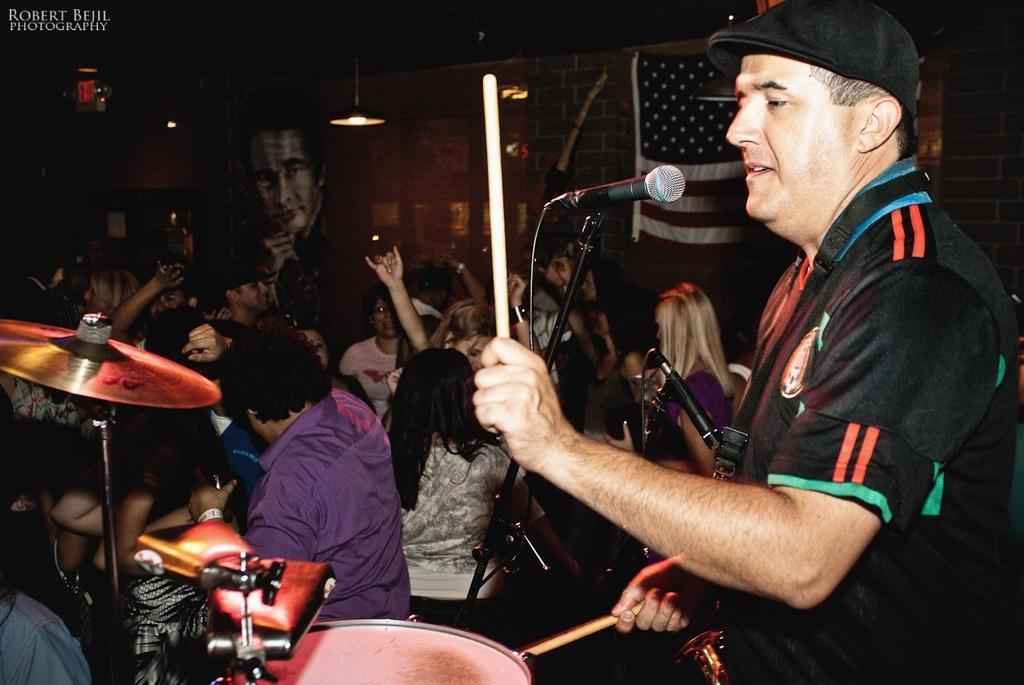How would you summarize this image in a sentence or two? In this picture we can see man who is playing drums. This is mike. Here we can see some musical instruments. And there is a light. 